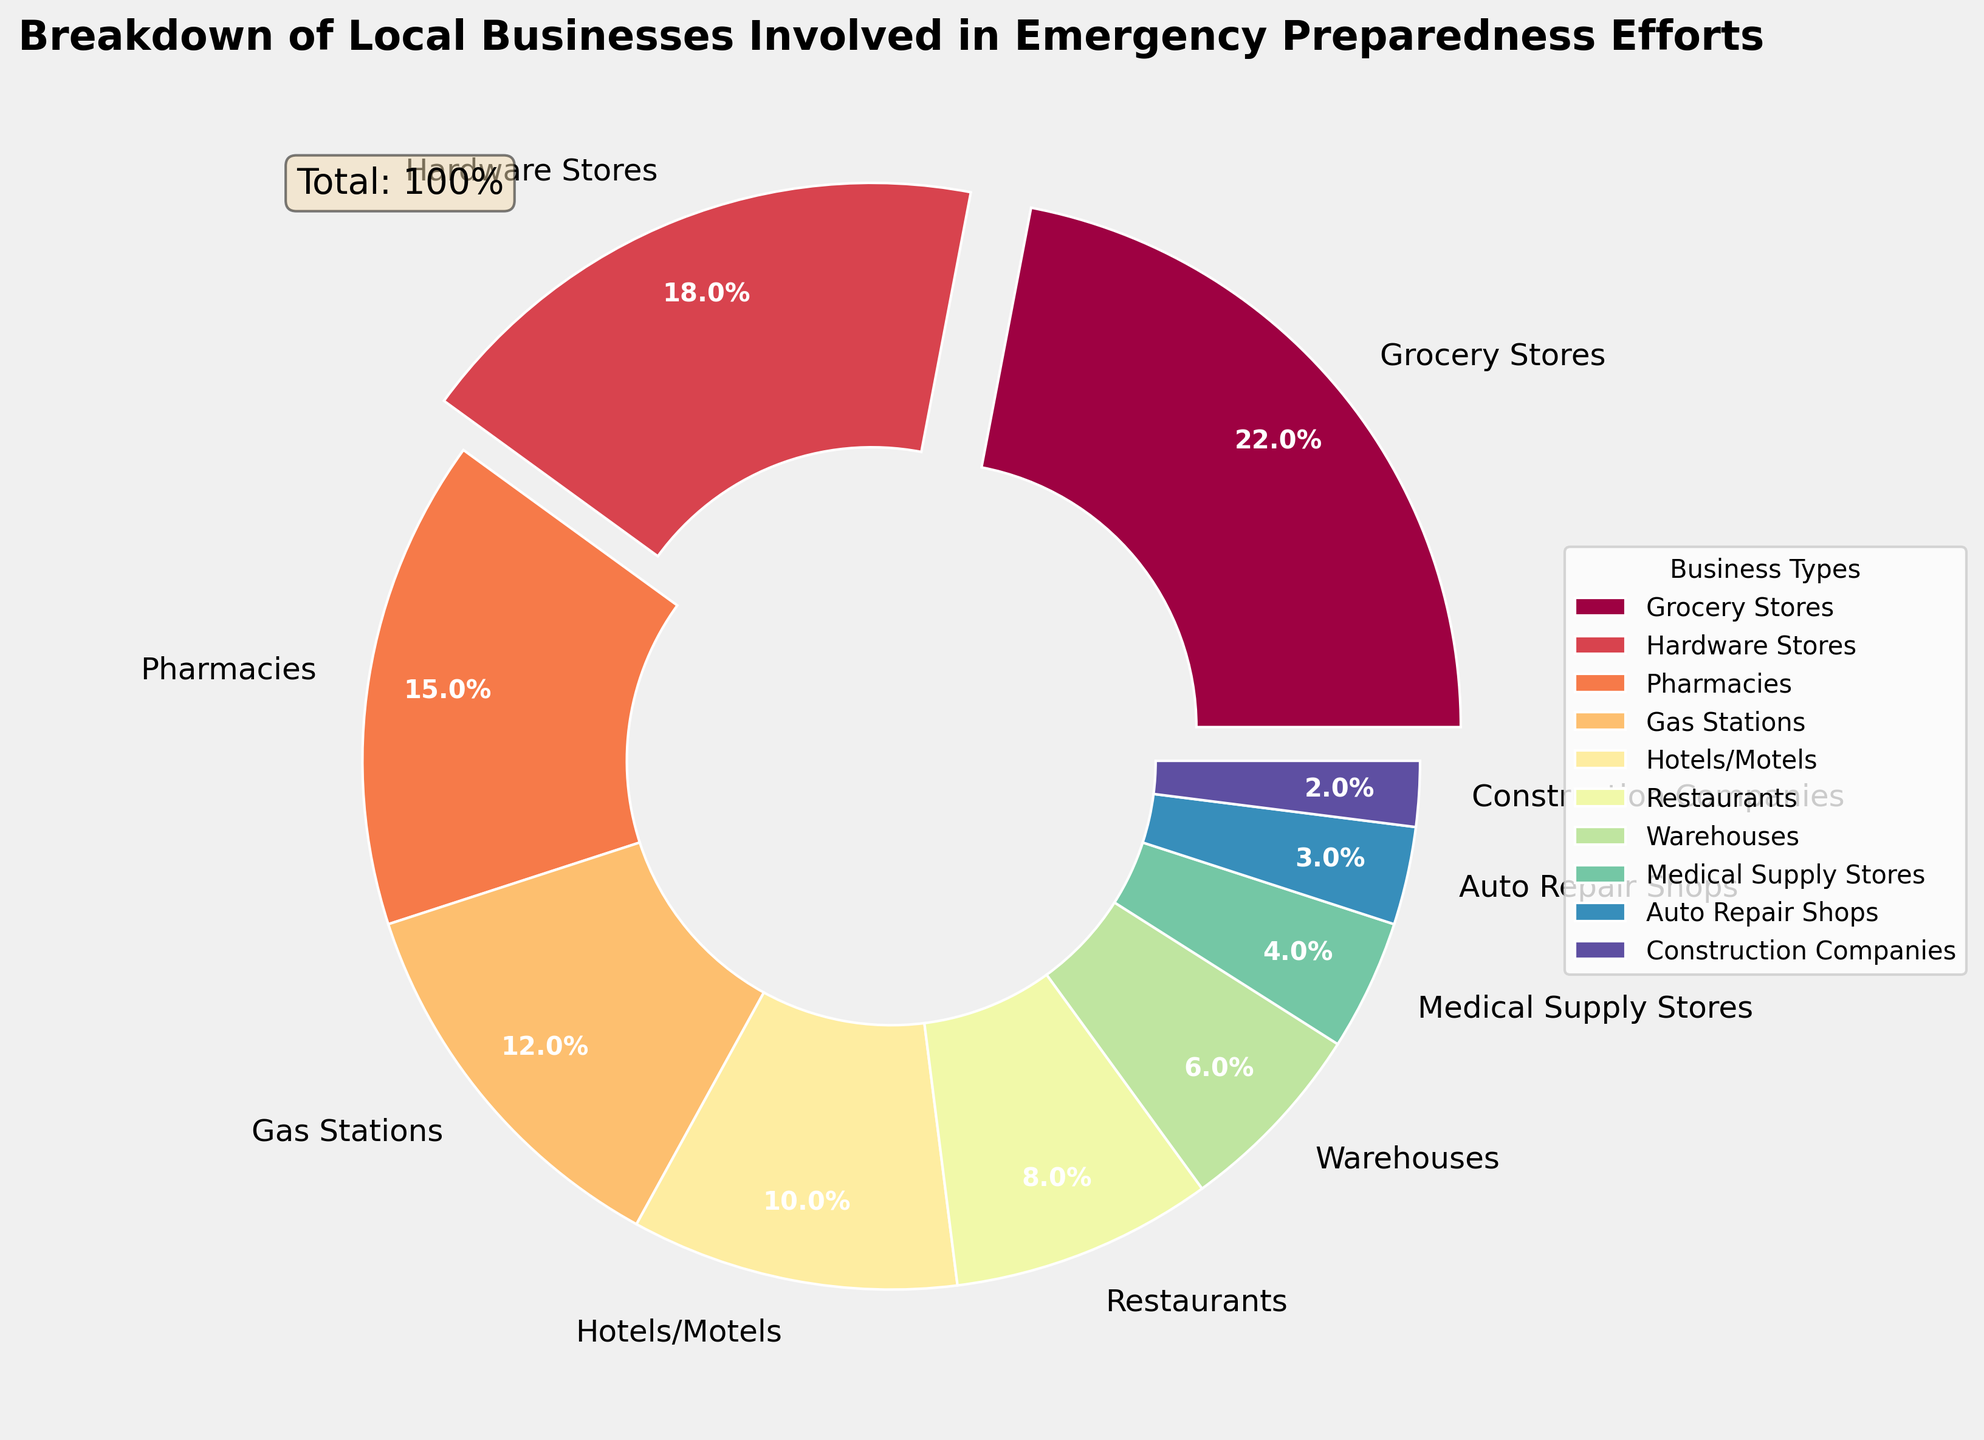How many business types have more than 10% involvement? First, identify the sections with percentages greater than 10%: Grocery Stores (22%), Hardware Stores (18%), Pharmacies (15%), and Gas Stations (12%). Count these sections to get the total number.
Answer: 4 Which business type has the smallest percentage involvement? Identify the section with the smallest percentage: Construction Companies at 2%.
Answer: Construction Companies What is the total percentage of the top three business types involved in emergency preparedness? Sum the percentages of the top three business types: Grocery Stores (22%), Hardware Stores (18%), and Pharmacies (15%). The total is 22% + 18% + 15%.
Answer: 55% How much more involved are Grocery Stores compared to Restaurants? Subtract the percentage of Restaurants from the percentage of Grocery Stores: 22% - 8%.
Answer: 14% What is the combined percentage of businesses with less than 5% involvement? Add the percentages of Medical Supply Stores (4%), Auto Repair Shops (3%), and Construction Companies (2%): 4% + 3% + 2%.
Answer: 9% Does the combination of Hotels/Motels and Restaurants exceed the involvement of Hardware Stores? Add the percentages of Hotels/Motels (10%) and Restaurants (8%): 10% + 8% = 18%. Since Hardware Stores are at 18%, the combination is equal to Hardware Stores.
Answer: No Which business type is the most involved in emergency preparedness after Grocery Stores and Hardware Stores? The third highest percentage is from Pharmacies at 15%.
Answer: Pharmacies How much more combined involvement do Grocery Stores and Hardware Stores have compared to Gas Stations and Restaurants? Calculate the total for Grocery Stores and Hardware Stores: 22% + 18% = 40%. Calculate the total for Gas Stations and Restaurants: 12% + 8% = 20%. Subtract the second total from the first: 40% - 20%.
Answer: 20% What percentage of the involvement is represented by Warehouses and Construction Companies combined? Add the percentages of Warehouses (6%) and Construction Companies (2%): 6% + 2%.
Answer: 8% Which business type between Auto Repair Shops and Medical Supply Stores has a higher involvement? Compare the percentages: Auto Repair Shops have 3% and Medical Supply Stores have 4%.
Answer: Medical Supply Stores 